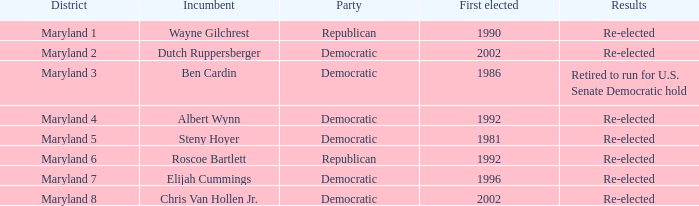What are the findings for the incumbent who was originally elected in 1996? Re-elected. 